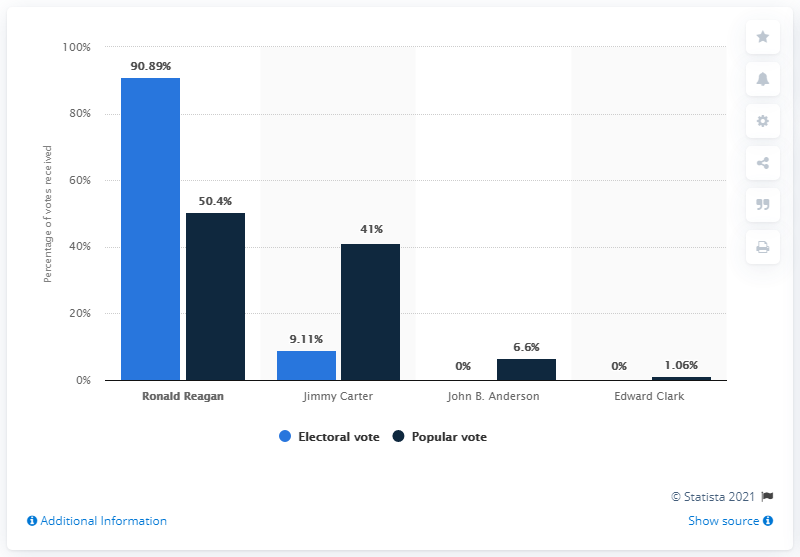Outline some significant characteristics in this image. Ronald Reagan, who had been a major figure in the Republican Party for over a decade, played a significant role in shaping the political landscape of the United States. John B. Anderson was the independent candidate in the 1980 US presidential election. In 1980, Jimmy Carter was the incumbent president of the Democratic Party. 